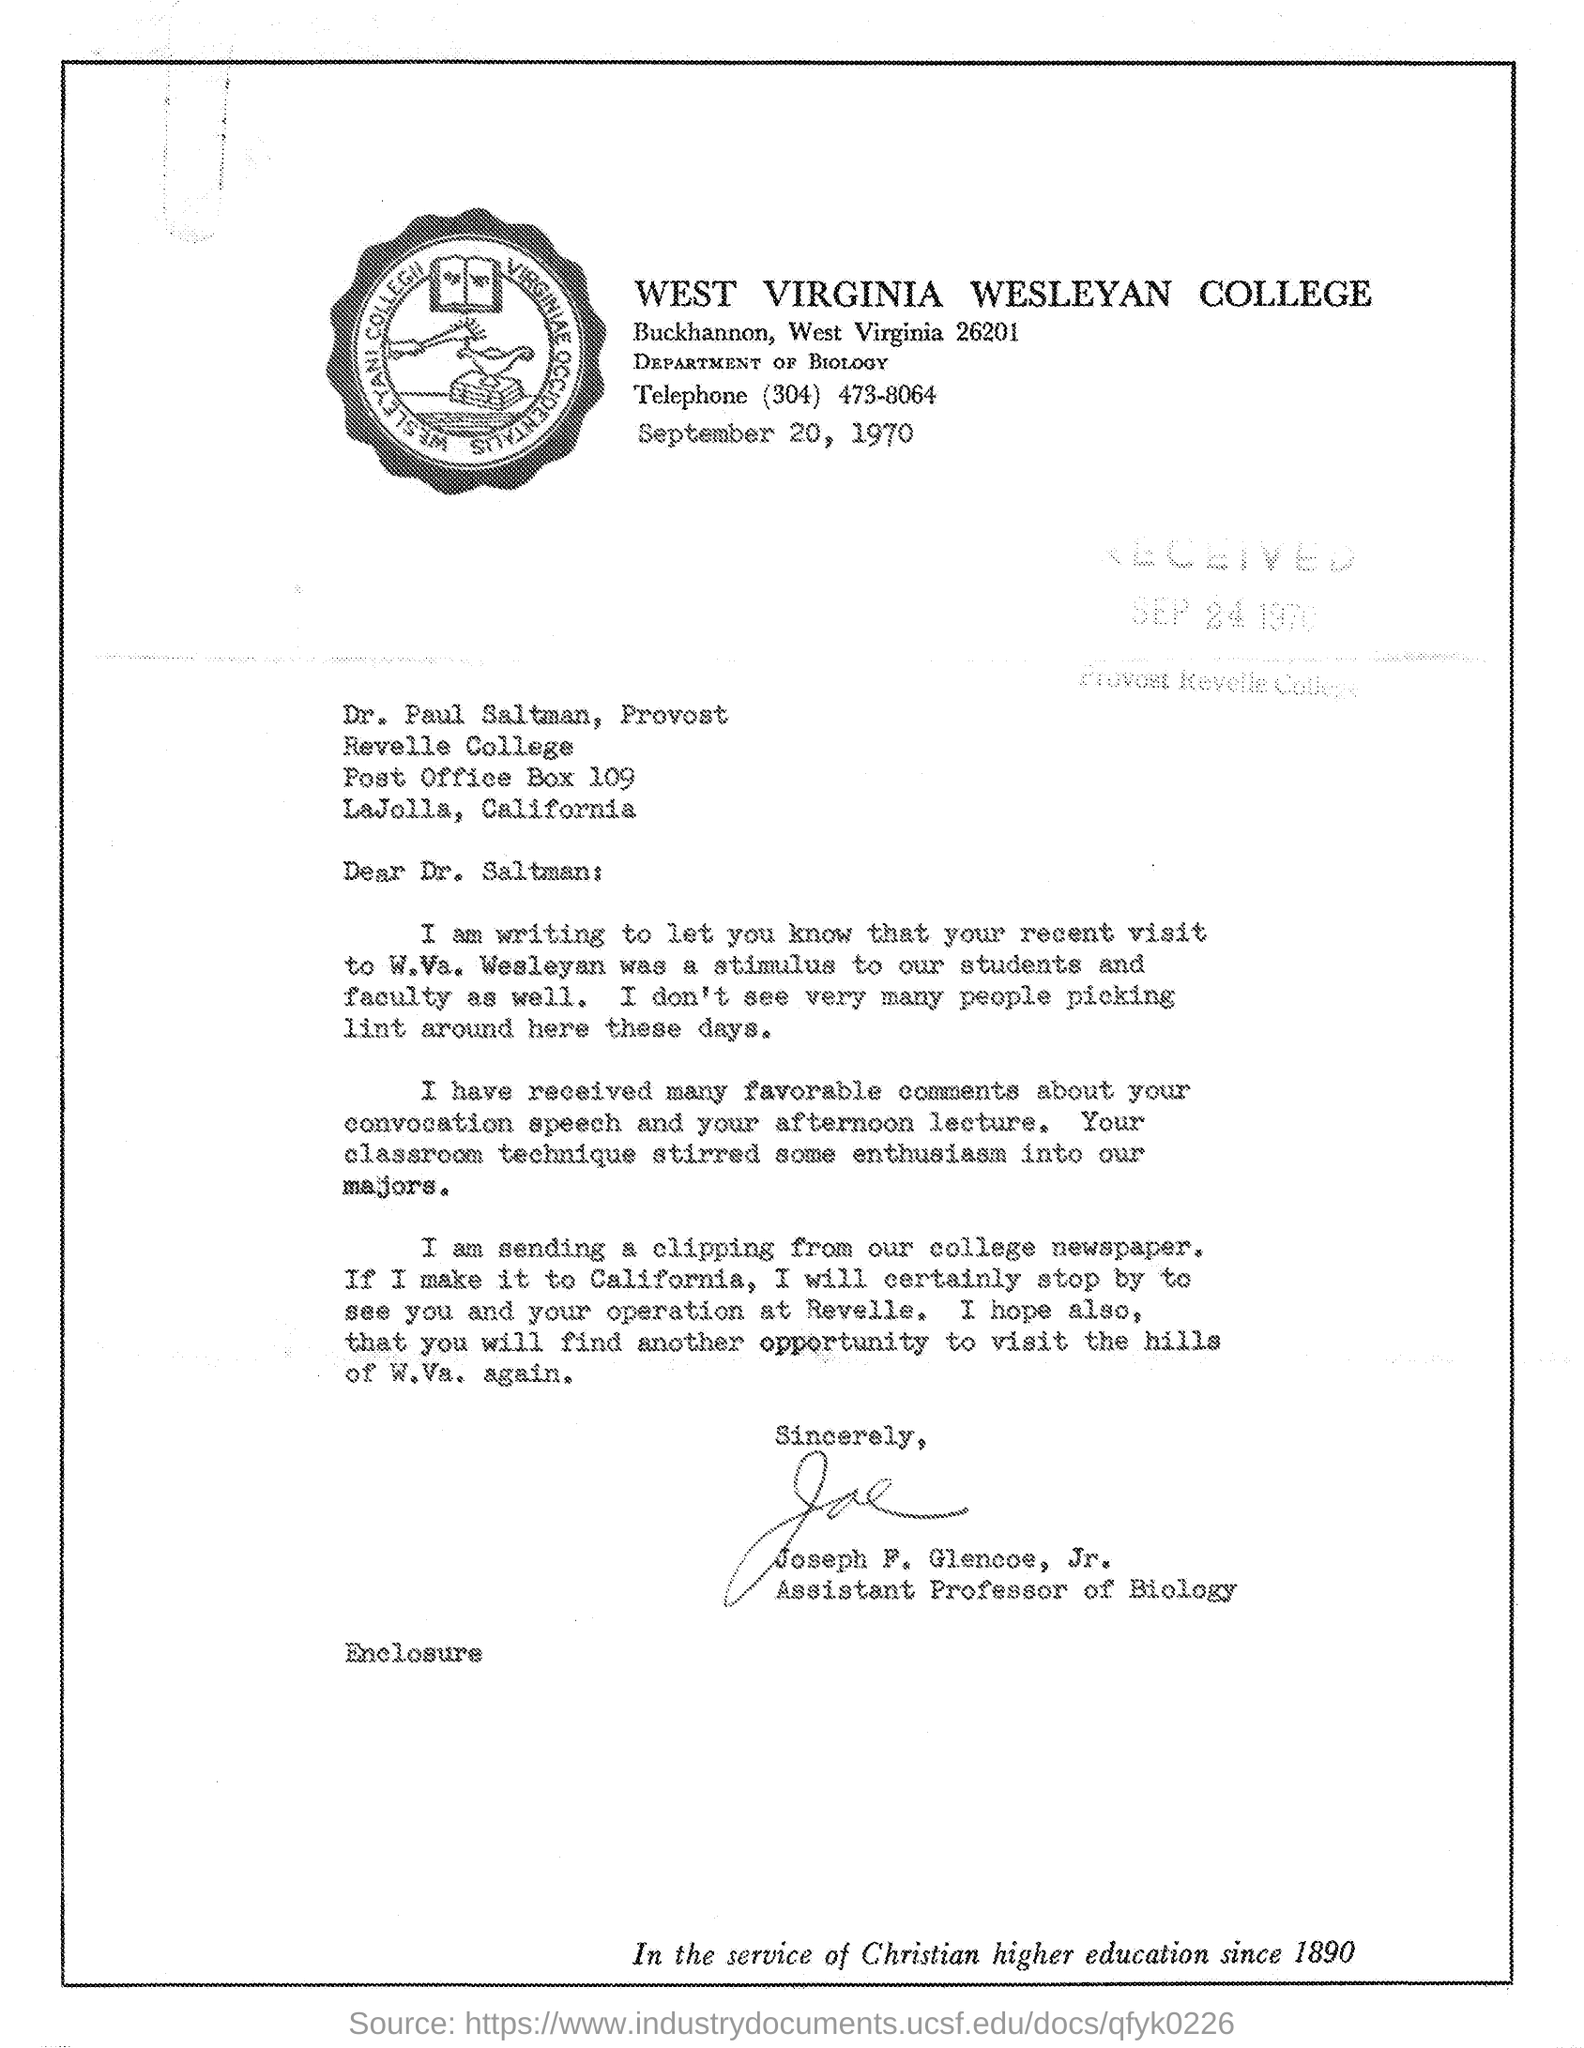Identify some key points in this picture. Joseph F. Glencoe is an Associate Professor of Biology. 